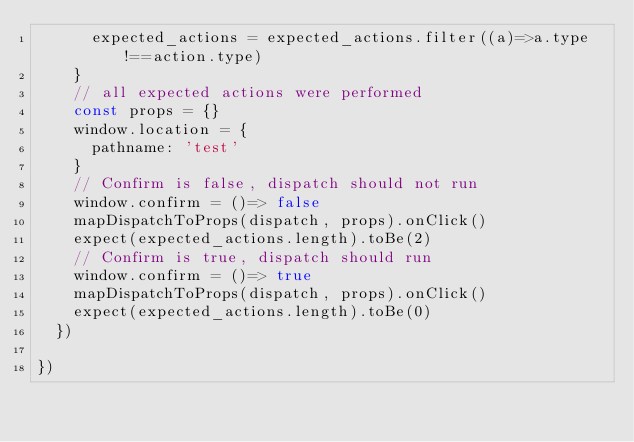Convert code to text. <code><loc_0><loc_0><loc_500><loc_500><_JavaScript_>      expected_actions = expected_actions.filter((a)=>a.type!==action.type)
    }
    // all expected actions were performed
    const props = {}
    window.location = {
      pathname: 'test'
    }
    // Confirm is false, dispatch should not run
    window.confirm = ()=> false
    mapDispatchToProps(dispatch, props).onClick()
    expect(expected_actions.length).toBe(2)
    // Confirm is true, dispatch should run
    window.confirm = ()=> true
    mapDispatchToProps(dispatch, props).onClick()
    expect(expected_actions.length).toBe(0)
  })

})
</code> 